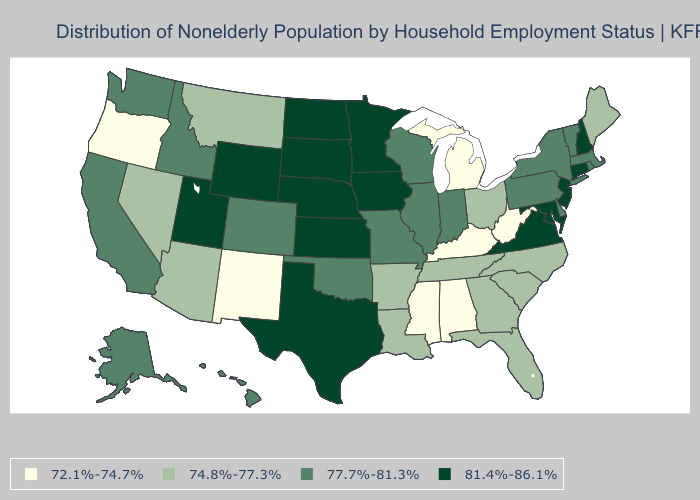Name the states that have a value in the range 77.7%-81.3%?
Short answer required. Alaska, California, Colorado, Delaware, Hawaii, Idaho, Illinois, Indiana, Massachusetts, Missouri, New York, Oklahoma, Pennsylvania, Rhode Island, Vermont, Washington, Wisconsin. Which states have the highest value in the USA?
Write a very short answer. Connecticut, Iowa, Kansas, Maryland, Minnesota, Nebraska, New Hampshire, New Jersey, North Dakota, South Dakota, Texas, Utah, Virginia, Wyoming. Does New Mexico have the highest value in the USA?
Short answer required. No. Is the legend a continuous bar?
Quick response, please. No. What is the value of Arkansas?
Be succinct. 74.8%-77.3%. Name the states that have a value in the range 74.8%-77.3%?
Answer briefly. Arizona, Arkansas, Florida, Georgia, Louisiana, Maine, Montana, Nevada, North Carolina, Ohio, South Carolina, Tennessee. What is the value of Alaska?
Answer briefly. 77.7%-81.3%. Name the states that have a value in the range 77.7%-81.3%?
Answer briefly. Alaska, California, Colorado, Delaware, Hawaii, Idaho, Illinois, Indiana, Massachusetts, Missouri, New York, Oklahoma, Pennsylvania, Rhode Island, Vermont, Washington, Wisconsin. Which states have the lowest value in the West?
Write a very short answer. New Mexico, Oregon. What is the value of Oklahoma?
Concise answer only. 77.7%-81.3%. Name the states that have a value in the range 77.7%-81.3%?
Answer briefly. Alaska, California, Colorado, Delaware, Hawaii, Idaho, Illinois, Indiana, Massachusetts, Missouri, New York, Oklahoma, Pennsylvania, Rhode Island, Vermont, Washington, Wisconsin. Name the states that have a value in the range 72.1%-74.7%?
Concise answer only. Alabama, Kentucky, Michigan, Mississippi, New Mexico, Oregon, West Virginia. What is the value of Mississippi?
Short answer required. 72.1%-74.7%. Does Vermont have the lowest value in the Northeast?
Give a very brief answer. No. What is the value of North Carolina?
Answer briefly. 74.8%-77.3%. 